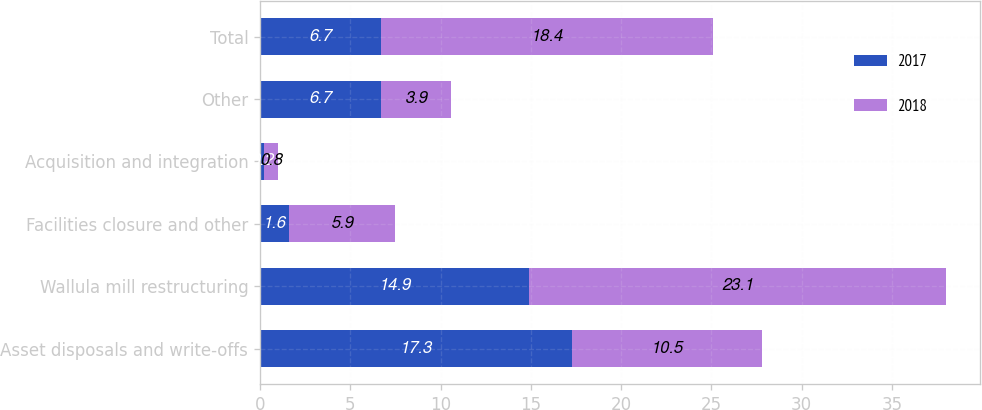Convert chart. <chart><loc_0><loc_0><loc_500><loc_500><stacked_bar_chart><ecel><fcel>Asset disposals and write-offs<fcel>Wallula mill restructuring<fcel>Facilities closure and other<fcel>Acquisition and integration<fcel>Other<fcel>Total<nl><fcel>2017<fcel>17.3<fcel>14.9<fcel>1.6<fcel>0.2<fcel>6.7<fcel>6.7<nl><fcel>2018<fcel>10.5<fcel>23.1<fcel>5.9<fcel>0.8<fcel>3.9<fcel>18.4<nl></chart> 